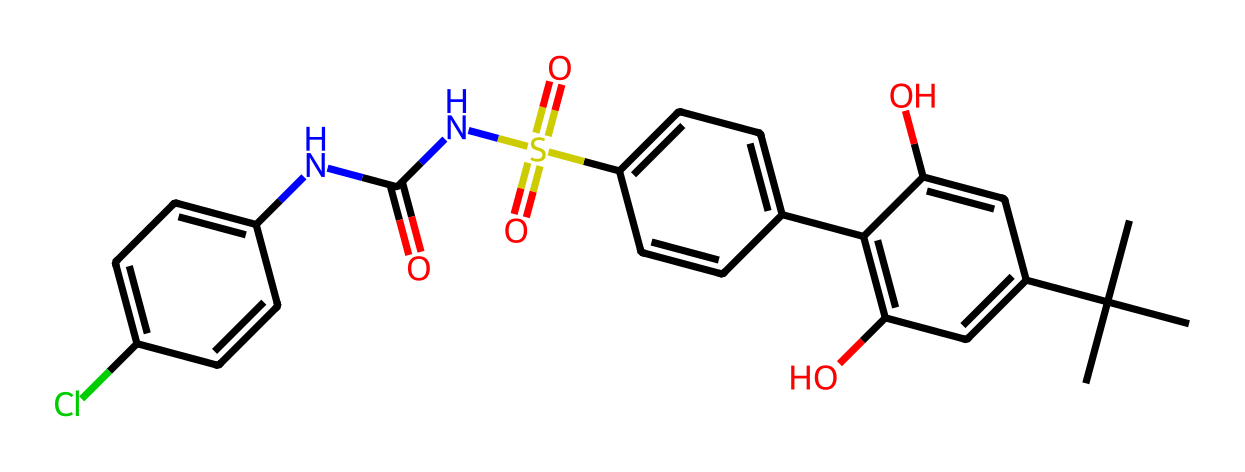What is the main functional group present in this chemical? The chemical contains a sulfonamide group (indicated by the sulfur atom bonded to two oxygen atoms and a nitrogen). This is a distinguishing feature of many artificial sweeteners.
Answer: sulfonamide How many rings are present in this chemical structure? The structure shows two distinct aromatic rings connected by functional groups. Each ring consists of a planar arrangement of carbon atoms, totaling two rings.
Answer: 2 Does this chemical contain any halogen atoms? The presence of a chlorine atom (noted by the 'Cl' in the structure) indicates that this chemical does contain a halogen.
Answer: yes What type of interaction would this chemical most likely have with water? As a non-electrolyte, this chemical does not ionize in water and would primarily exhibit Van der Waals interactions without forming ions.
Answer: Van der Waals interactions Which part of the chemical gives it sweetness? The arrangement of the nitrogen and sulfonamide groups along with the connectivity of carbon atoms creates a non-electrolyte sweetener character recognized in structures like this, implying that the specific configuration is responsible for sweetness.
Answer: nitrogen and sulfonamide groups 